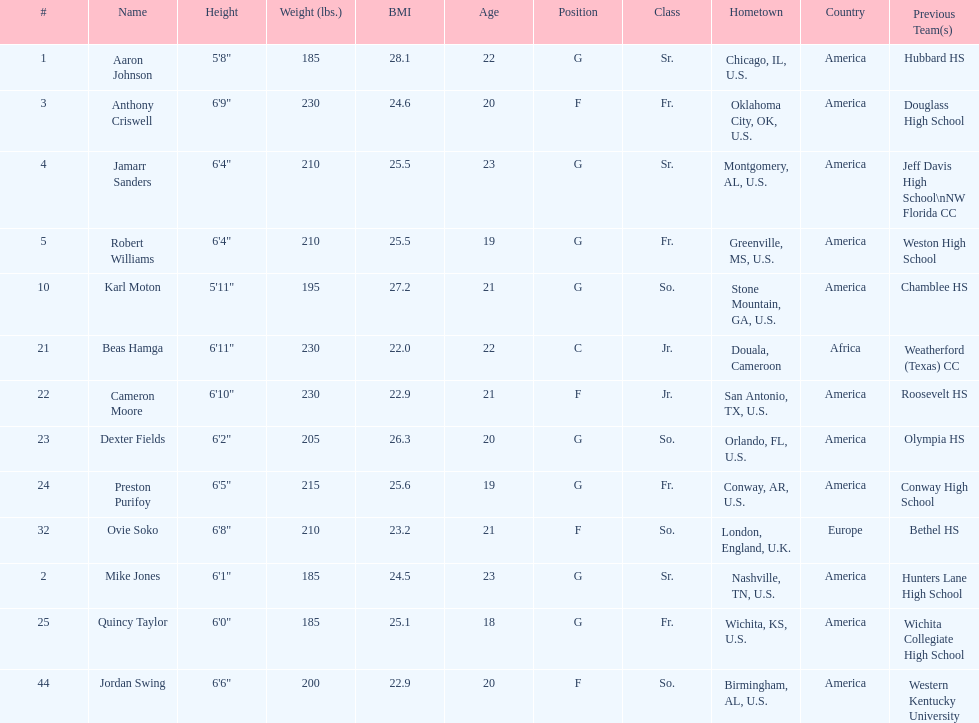How many total forwards are on the team? 4. 